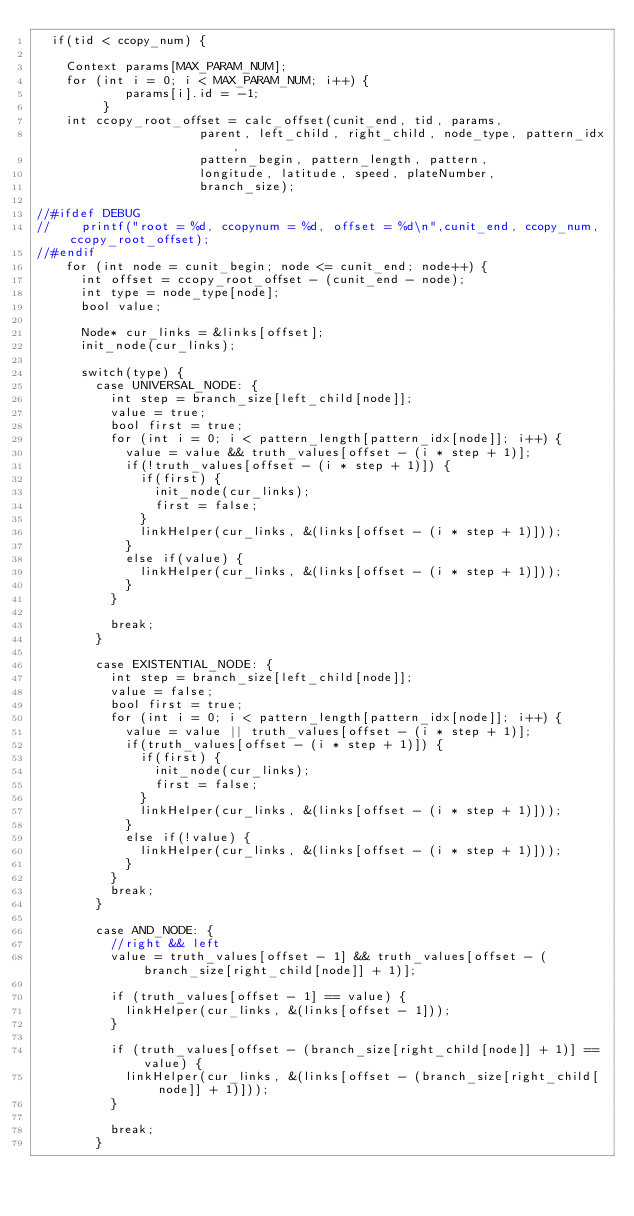<code> <loc_0><loc_0><loc_500><loc_500><_Cuda_>	if(tid < ccopy_num) {

		Context params[MAX_PARAM_NUM];
		for (int i = 0; i < MAX_PARAM_NUM; i++) {
            params[i].id = -1;
         }
		int ccopy_root_offset = calc_offset(cunit_end, tid, params,
											parent, left_child, right_child, node_type, pattern_idx,
											pattern_begin, pattern_length, pattern,
											longitude, latitude, speed, plateNumber,
											branch_size);

//#ifdef DEBUG
//		printf("root = %d, ccopynum = %d, offset = %d\n",cunit_end, ccopy_num, ccopy_root_offset);
//#endif
		for (int node = cunit_begin; node <= cunit_end; node++) {
			int offset = ccopy_root_offset - (cunit_end - node);
			int type = node_type[node];
			bool value;

			Node* cur_links = &links[offset];
			init_node(cur_links);

			switch(type) {
				case UNIVERSAL_NODE: {
					int step = branch_size[left_child[node]];
					value = true;
					bool first = true;
					for (int i = 0; i < pattern_length[pattern_idx[node]]; i++) {
						value = value && truth_values[offset - (i * step + 1)];
						if(!truth_values[offset - (i * step + 1)]) {
							if(first) {
								init_node(cur_links);
								first = false;
							}
							linkHelper(cur_links, &(links[offset - (i * step + 1)]));
						}
						else if(value) {
							linkHelper(cur_links, &(links[offset - (i * step + 1)]));
						}
					}

					break;
				}

				case EXISTENTIAL_NODE: {
					int step = branch_size[left_child[node]];
					value = false;
					bool first = true;
					for (int i = 0; i < pattern_length[pattern_idx[node]]; i++) {
						value = value || truth_values[offset - (i * step + 1)];
						if(truth_values[offset - (i * step + 1)]) {
							if(first) {
								init_node(cur_links);
								first = false;
							}
							linkHelper(cur_links, &(links[offset - (i * step + 1)]));
						}
						else if(!value) {
							linkHelper(cur_links, &(links[offset - (i * step + 1)]));
						}
					}
					break;
				}

				case AND_NODE: {
					//right && left
					value = truth_values[offset - 1] && truth_values[offset - (branch_size[right_child[node]] + 1)];

					if (truth_values[offset - 1] == value) {
						linkHelper(cur_links, &(links[offset - 1]));
					}

					if (truth_values[offset - (branch_size[right_child[node]] + 1)] == value) {
						linkHelper(cur_links, &(links[offset - (branch_size[right_child[node]] + 1)]));
					}

					break;
				}</code> 